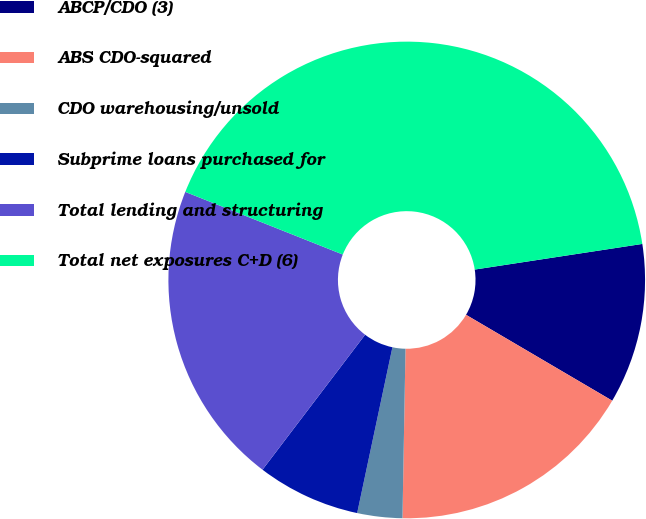Convert chart to OTSL. <chart><loc_0><loc_0><loc_500><loc_500><pie_chart><fcel>ABCP/CDO (3)<fcel>ABS CDO-squared<fcel>CDO warehousing/unsold<fcel>Subprime loans purchased for<fcel>Total lending and structuring<fcel>Total net exposures C+D (6)<nl><fcel>10.87%<fcel>16.83%<fcel>3.05%<fcel>7.01%<fcel>20.68%<fcel>41.56%<nl></chart> 